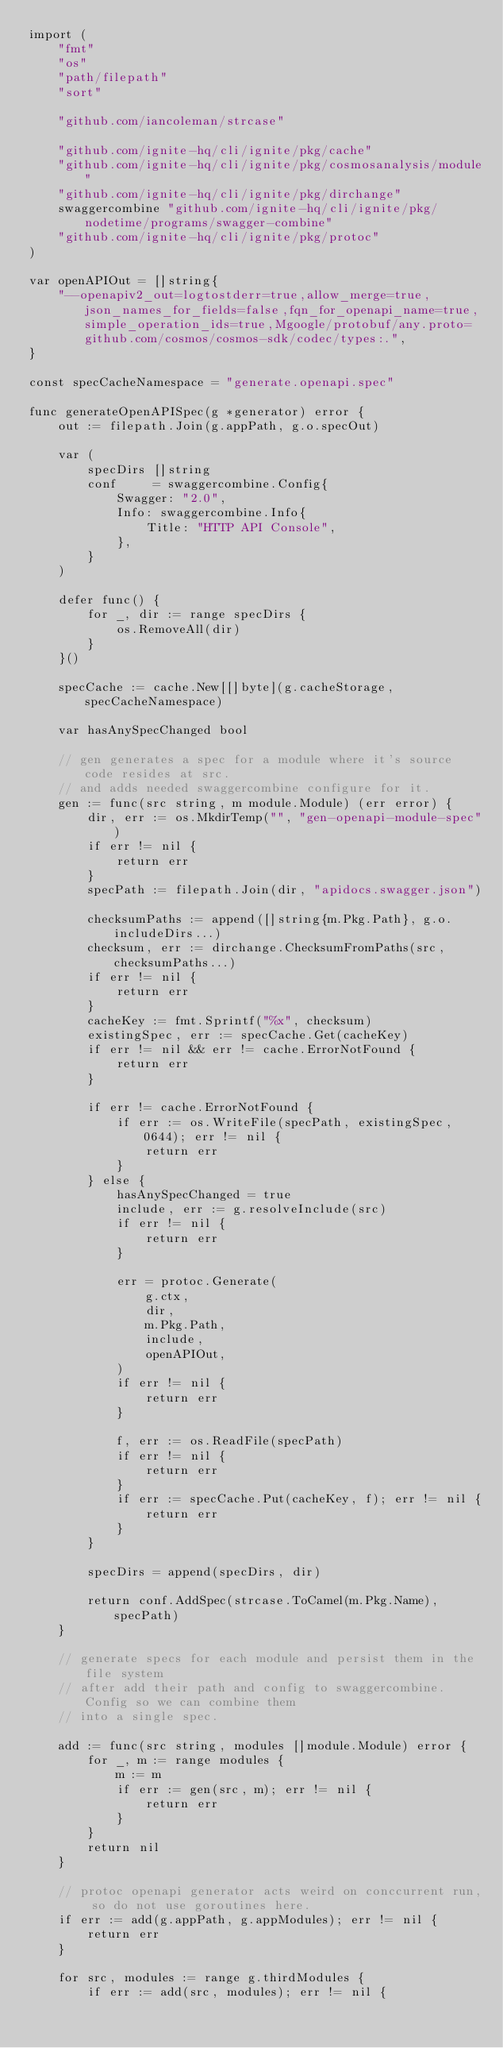<code> <loc_0><loc_0><loc_500><loc_500><_Go_>import (
	"fmt"
	"os"
	"path/filepath"
	"sort"

	"github.com/iancoleman/strcase"

	"github.com/ignite-hq/cli/ignite/pkg/cache"
	"github.com/ignite-hq/cli/ignite/pkg/cosmosanalysis/module"
	"github.com/ignite-hq/cli/ignite/pkg/dirchange"
	swaggercombine "github.com/ignite-hq/cli/ignite/pkg/nodetime/programs/swagger-combine"
	"github.com/ignite-hq/cli/ignite/pkg/protoc"
)

var openAPIOut = []string{
	"--openapiv2_out=logtostderr=true,allow_merge=true,json_names_for_fields=false,fqn_for_openapi_name=true,simple_operation_ids=true,Mgoogle/protobuf/any.proto=github.com/cosmos/cosmos-sdk/codec/types:.",
}

const specCacheNamespace = "generate.openapi.spec"

func generateOpenAPISpec(g *generator) error {
	out := filepath.Join(g.appPath, g.o.specOut)

	var (
		specDirs []string
		conf     = swaggercombine.Config{
			Swagger: "2.0",
			Info: swaggercombine.Info{
				Title: "HTTP API Console",
			},
		}
	)

	defer func() {
		for _, dir := range specDirs {
			os.RemoveAll(dir)
		}
	}()

	specCache := cache.New[[]byte](g.cacheStorage, specCacheNamespace)

	var hasAnySpecChanged bool

	// gen generates a spec for a module where it's source code resides at src.
	// and adds needed swaggercombine configure for it.
	gen := func(src string, m module.Module) (err error) {
		dir, err := os.MkdirTemp("", "gen-openapi-module-spec")
		if err != nil {
			return err
		}
		specPath := filepath.Join(dir, "apidocs.swagger.json")

		checksumPaths := append([]string{m.Pkg.Path}, g.o.includeDirs...)
		checksum, err := dirchange.ChecksumFromPaths(src, checksumPaths...)
		if err != nil {
			return err
		}
		cacheKey := fmt.Sprintf("%x", checksum)
		existingSpec, err := specCache.Get(cacheKey)
		if err != nil && err != cache.ErrorNotFound {
			return err
		}

		if err != cache.ErrorNotFound {
			if err := os.WriteFile(specPath, existingSpec, 0644); err != nil {
				return err
			}
		} else {
			hasAnySpecChanged = true
			include, err := g.resolveInclude(src)
			if err != nil {
				return err
			}

			err = protoc.Generate(
				g.ctx,
				dir,
				m.Pkg.Path,
				include,
				openAPIOut,
			)
			if err != nil {
				return err
			}

			f, err := os.ReadFile(specPath)
			if err != nil {
				return err
			}
			if err := specCache.Put(cacheKey, f); err != nil {
				return err
			}
		}

		specDirs = append(specDirs, dir)

		return conf.AddSpec(strcase.ToCamel(m.Pkg.Name), specPath)
	}

	// generate specs for each module and persist them in the file system
	// after add their path and config to swaggercombine.Config so we can combine them
	// into a single spec.

	add := func(src string, modules []module.Module) error {
		for _, m := range modules {
			m := m
			if err := gen(src, m); err != nil {
				return err
			}
		}
		return nil
	}

	// protoc openapi generator acts weird on conccurrent run, so do not use goroutines here.
	if err := add(g.appPath, g.appModules); err != nil {
		return err
	}

	for src, modules := range g.thirdModules {
		if err := add(src, modules); err != nil {</code> 